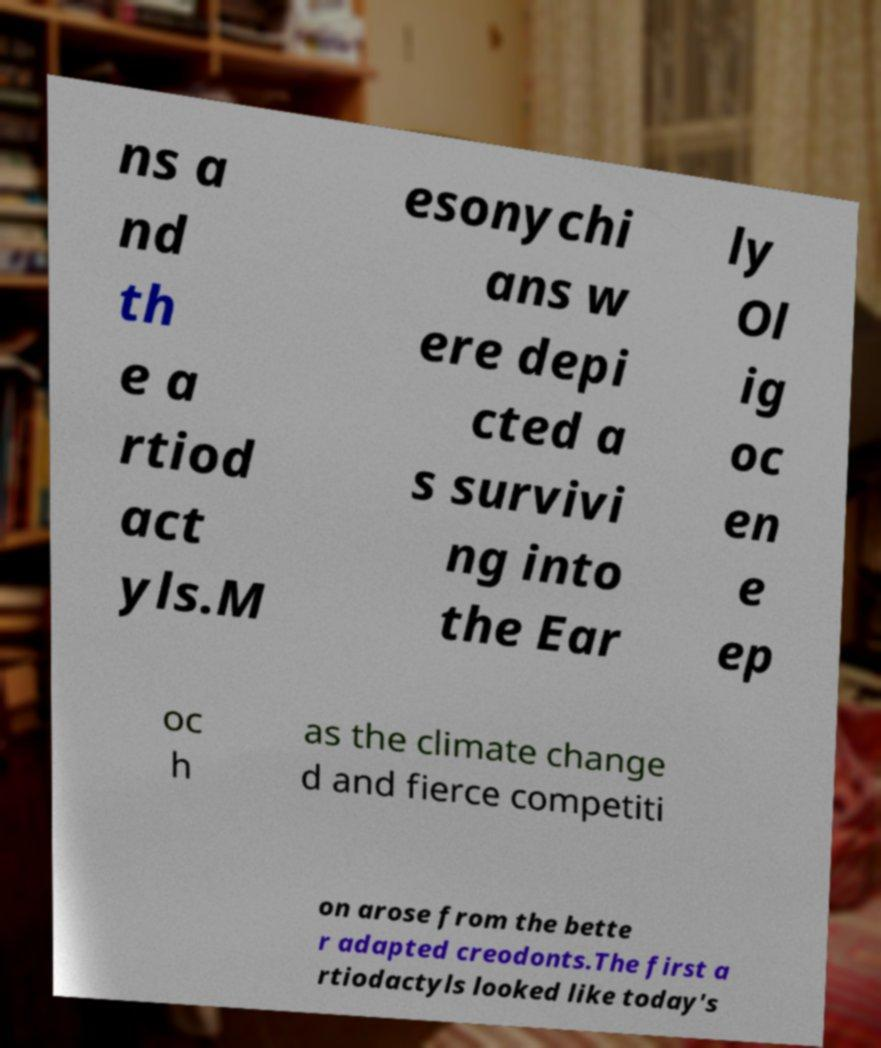Please read and relay the text visible in this image. What does it say? ns a nd th e a rtiod act yls.M esonychi ans w ere depi cted a s survivi ng into the Ear ly Ol ig oc en e ep oc h as the climate change d and fierce competiti on arose from the bette r adapted creodonts.The first a rtiodactyls looked like today's 